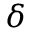Convert formula to latex. <formula><loc_0><loc_0><loc_500><loc_500>\delta</formula> 